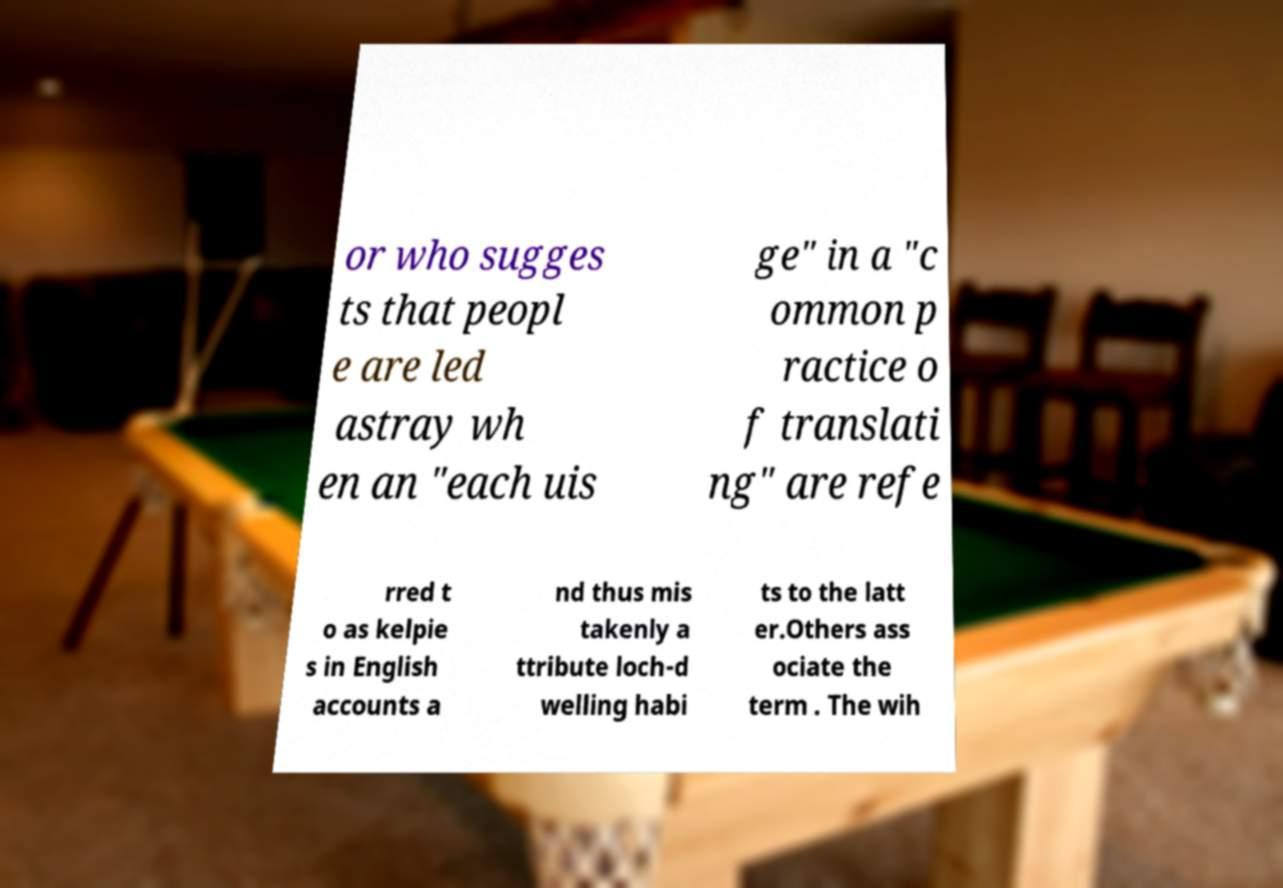Can you accurately transcribe the text from the provided image for me? or who sugges ts that peopl e are led astray wh en an "each uis ge" in a "c ommon p ractice o f translati ng" are refe rred t o as kelpie s in English accounts a nd thus mis takenly a ttribute loch-d welling habi ts to the latt er.Others ass ociate the term . The wih 